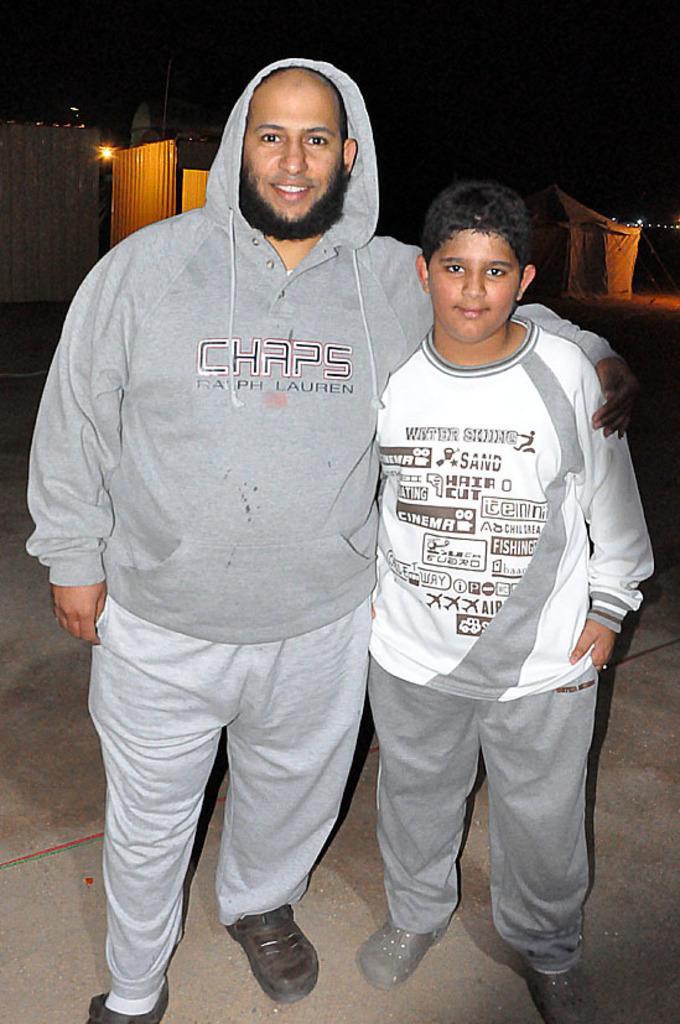Can you describe this image briefly? In the foreground of the picture there are two person standing. In the background there are buildings, lights and other objects. 